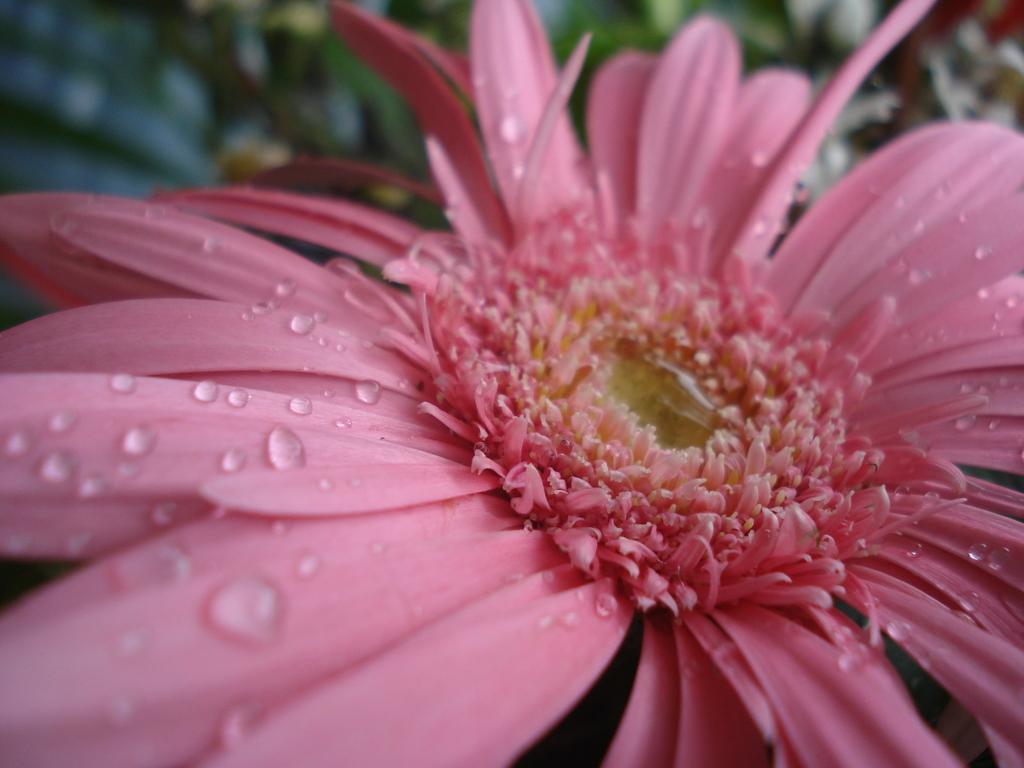Can you describe this image briefly? In the picture we can see a flower on it, we can see some water droplets and in the background, we can see some plants which are not clearly visible. 